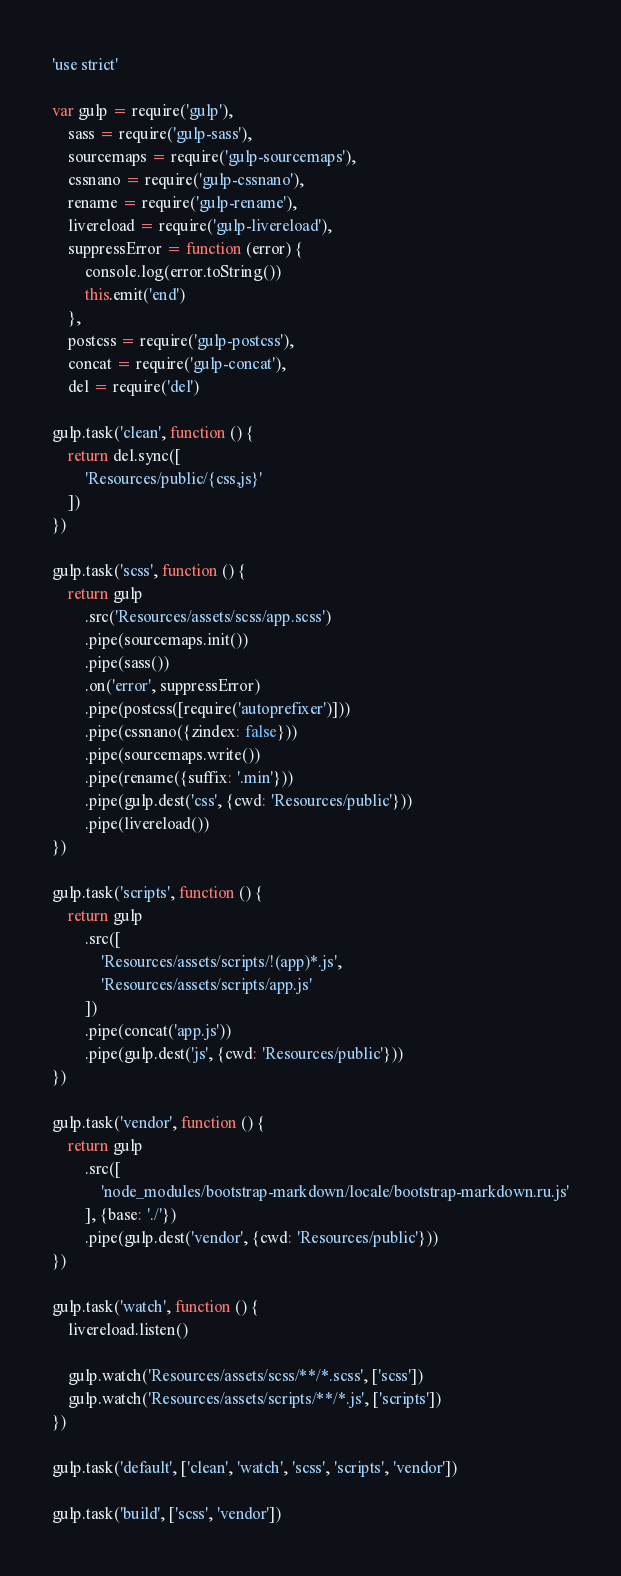Convert code to text. <code><loc_0><loc_0><loc_500><loc_500><_JavaScript_>'use strict'

var gulp = require('gulp'),
    sass = require('gulp-sass'),
    sourcemaps = require('gulp-sourcemaps'),
    cssnano = require('gulp-cssnano'),
    rename = require('gulp-rename'),
    livereload = require('gulp-livereload'),
    suppressError = function (error) {
        console.log(error.toString())
        this.emit('end')
    },
    postcss = require('gulp-postcss'),
    concat = require('gulp-concat'),
    del = require('del')

gulp.task('clean', function () {
    return del.sync([
        'Resources/public/{css,js}'
    ])
})

gulp.task('scss', function () {
    return gulp
        .src('Resources/assets/scss/app.scss')
        .pipe(sourcemaps.init())
        .pipe(sass())
        .on('error', suppressError)
        .pipe(postcss([require('autoprefixer')]))
        .pipe(cssnano({zindex: false}))
        .pipe(sourcemaps.write())
        .pipe(rename({suffix: '.min'}))
        .pipe(gulp.dest('css', {cwd: 'Resources/public'}))
        .pipe(livereload())
})

gulp.task('scripts', function () {
    return gulp
        .src([
            'Resources/assets/scripts/!(app)*.js',
            'Resources/assets/scripts/app.js'
        ])
        .pipe(concat('app.js'))
        .pipe(gulp.dest('js', {cwd: 'Resources/public'}))
})

gulp.task('vendor', function () {
    return gulp
        .src([
            'node_modules/bootstrap-markdown/locale/bootstrap-markdown.ru.js'
        ], {base: './'})
        .pipe(gulp.dest('vendor', {cwd: 'Resources/public'}))
})

gulp.task('watch', function () {
    livereload.listen()

    gulp.watch('Resources/assets/scss/**/*.scss', ['scss'])
    gulp.watch('Resources/assets/scripts/**/*.js', ['scripts'])
})

gulp.task('default', ['clean', 'watch', 'scss', 'scripts', 'vendor'])

gulp.task('build', ['scss', 'vendor'])
</code> 